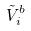Convert formula to latex. <formula><loc_0><loc_0><loc_500><loc_500>\tilde { V } _ { i } ^ { b }</formula> 